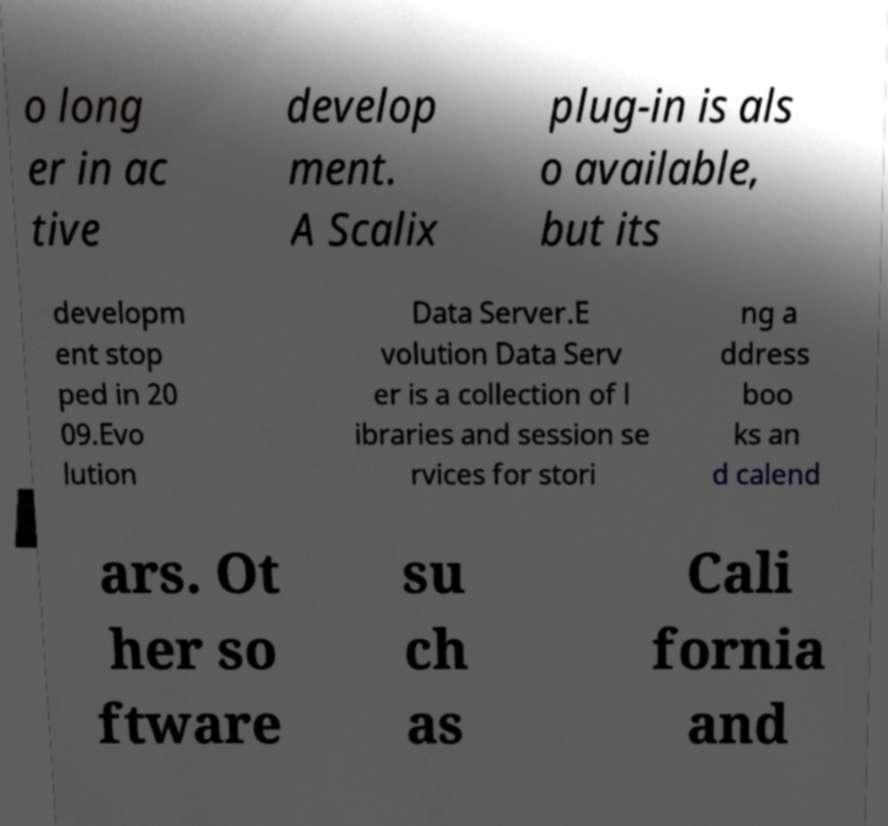For documentation purposes, I need the text within this image transcribed. Could you provide that? o long er in ac tive develop ment. A Scalix plug-in is als o available, but its developm ent stop ped in 20 09.Evo lution Data Server.E volution Data Serv er is a collection of l ibraries and session se rvices for stori ng a ddress boo ks an d calend ars. Ot her so ftware su ch as Cali fornia and 